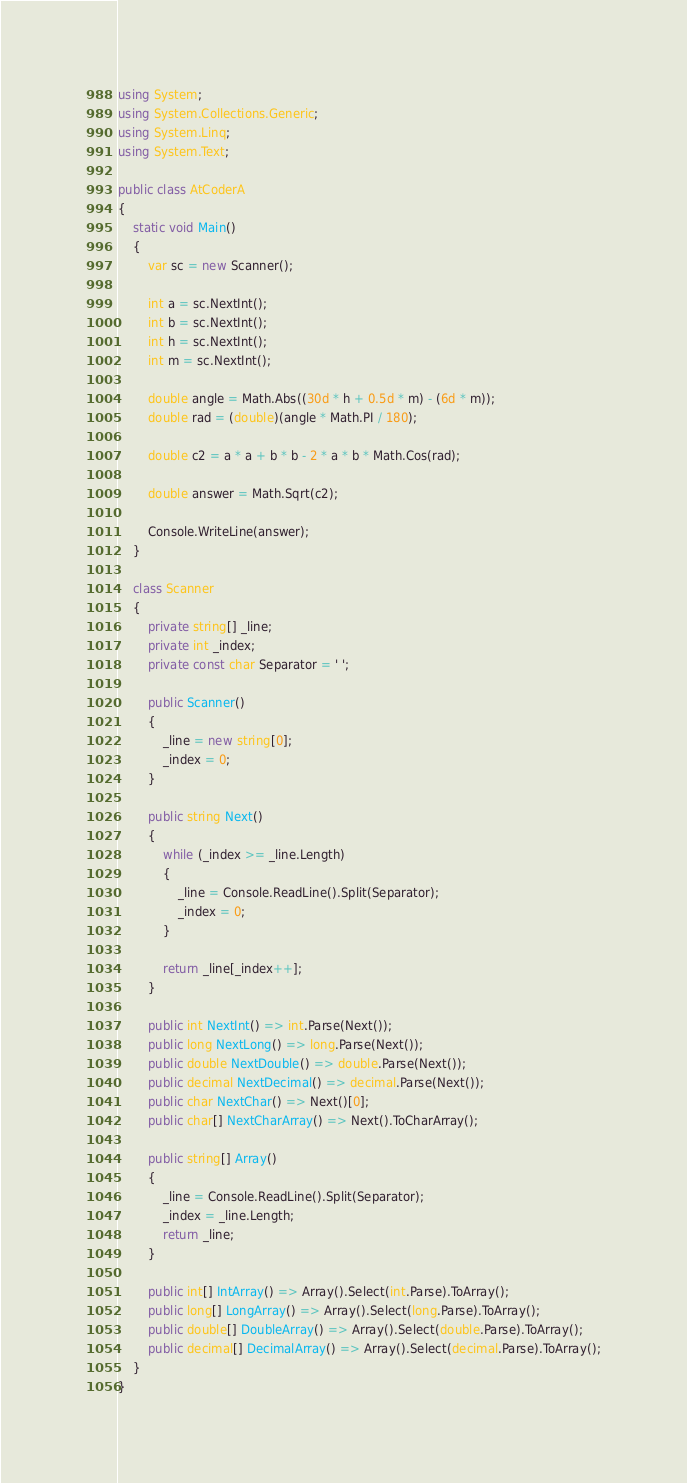Convert code to text. <code><loc_0><loc_0><loc_500><loc_500><_C#_>using System;
using System.Collections.Generic;
using System.Linq;
using System.Text;

public class AtCoderA
{
    static void Main()
    {
        var sc = new Scanner();

        int a = sc.NextInt();
        int b = sc.NextInt();
        int h = sc.NextInt();
        int m = sc.NextInt();

        double angle = Math.Abs((30d * h + 0.5d * m) - (6d * m));
        double rad = (double)(angle * Math.PI / 180);

        double c2 = a * a + b * b - 2 * a * b * Math.Cos(rad);

        double answer = Math.Sqrt(c2);

        Console.WriteLine(answer);
    }

    class Scanner
    {
        private string[] _line;
        private int _index;
        private const char Separator = ' ';

        public Scanner()
        {
            _line = new string[0];
            _index = 0;
        }

        public string Next()
        {
            while (_index >= _line.Length)
            {
                _line = Console.ReadLine().Split(Separator);
                _index = 0;
            }

            return _line[_index++];
        }

        public int NextInt() => int.Parse(Next());
        public long NextLong() => long.Parse(Next());
        public double NextDouble() => double.Parse(Next());
        public decimal NextDecimal() => decimal.Parse(Next());
        public char NextChar() => Next()[0];
        public char[] NextCharArray() => Next().ToCharArray();

        public string[] Array()
        {
            _line = Console.ReadLine().Split(Separator);
            _index = _line.Length;
            return _line;
        }

        public int[] IntArray() => Array().Select(int.Parse).ToArray();
        public long[] LongArray() => Array().Select(long.Parse).ToArray();
        public double[] DoubleArray() => Array().Select(double.Parse).ToArray();
        public decimal[] DecimalArray() => Array().Select(decimal.Parse).ToArray();
    }
}</code> 